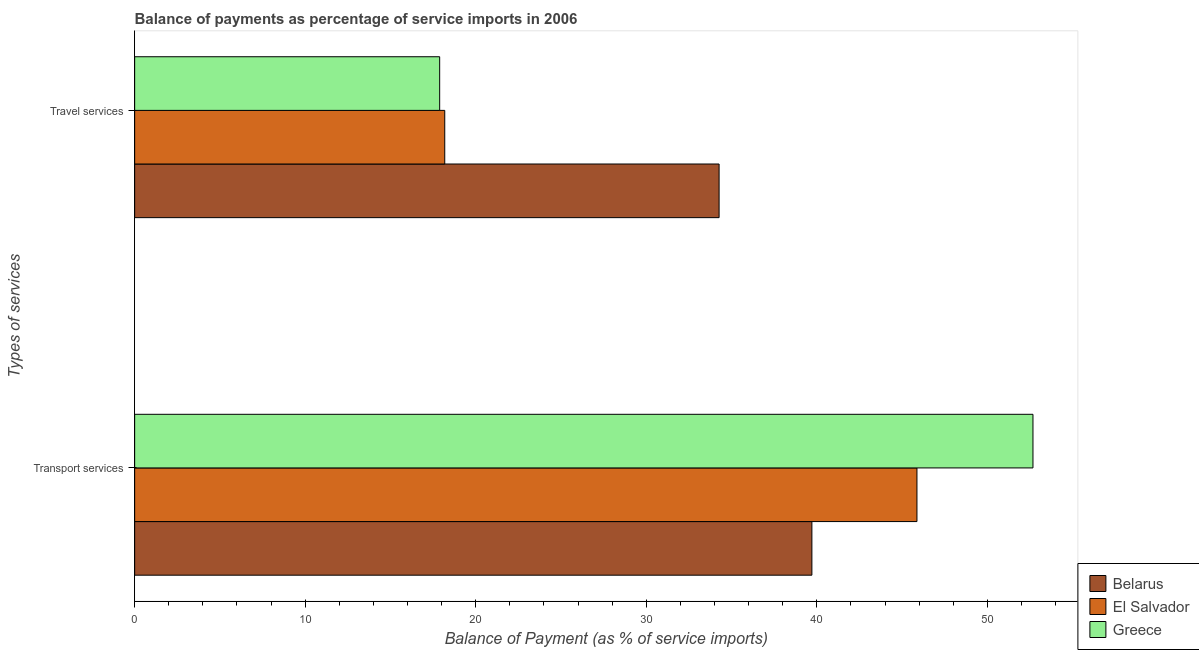How many different coloured bars are there?
Provide a succinct answer. 3. Are the number of bars per tick equal to the number of legend labels?
Keep it short and to the point. Yes. How many bars are there on the 2nd tick from the top?
Your answer should be very brief. 3. What is the label of the 1st group of bars from the top?
Ensure brevity in your answer.  Travel services. What is the balance of payments of travel services in El Salvador?
Offer a very short reply. 18.18. Across all countries, what is the maximum balance of payments of transport services?
Ensure brevity in your answer.  52.67. Across all countries, what is the minimum balance of payments of travel services?
Keep it short and to the point. 17.89. In which country was the balance of payments of transport services minimum?
Your answer should be compact. Belarus. What is the total balance of payments of transport services in the graph?
Offer a terse response. 138.26. What is the difference between the balance of payments of transport services in El Salvador and that in Belarus?
Make the answer very short. 6.16. What is the difference between the balance of payments of travel services in El Salvador and the balance of payments of transport services in Greece?
Offer a very short reply. -34.49. What is the average balance of payments of travel services per country?
Provide a succinct answer. 23.45. What is the difference between the balance of payments of travel services and balance of payments of transport services in El Salvador?
Ensure brevity in your answer.  -27.69. In how many countries, is the balance of payments of travel services greater than 38 %?
Offer a very short reply. 0. What is the ratio of the balance of payments of travel services in Greece to that in Belarus?
Your answer should be very brief. 0.52. Is the balance of payments of travel services in Greece less than that in El Salvador?
Offer a very short reply. Yes. What does the 2nd bar from the top in Travel services represents?
Ensure brevity in your answer.  El Salvador. What does the 2nd bar from the bottom in Transport services represents?
Offer a very short reply. El Salvador. Are all the bars in the graph horizontal?
Make the answer very short. Yes. How many countries are there in the graph?
Keep it short and to the point. 3. What is the difference between two consecutive major ticks on the X-axis?
Offer a very short reply. 10. Are the values on the major ticks of X-axis written in scientific E-notation?
Your answer should be very brief. No. Does the graph contain any zero values?
Offer a very short reply. No. How many legend labels are there?
Offer a terse response. 3. How are the legend labels stacked?
Make the answer very short. Vertical. What is the title of the graph?
Provide a succinct answer. Balance of payments as percentage of service imports in 2006. Does "OECD members" appear as one of the legend labels in the graph?
Your response must be concise. No. What is the label or title of the X-axis?
Provide a short and direct response. Balance of Payment (as % of service imports). What is the label or title of the Y-axis?
Your answer should be very brief. Types of services. What is the Balance of Payment (as % of service imports) in Belarus in Transport services?
Provide a succinct answer. 39.71. What is the Balance of Payment (as % of service imports) in El Salvador in Transport services?
Give a very brief answer. 45.87. What is the Balance of Payment (as % of service imports) of Greece in Transport services?
Your answer should be very brief. 52.67. What is the Balance of Payment (as % of service imports) of Belarus in Travel services?
Offer a terse response. 34.27. What is the Balance of Payment (as % of service imports) of El Salvador in Travel services?
Provide a short and direct response. 18.18. What is the Balance of Payment (as % of service imports) of Greece in Travel services?
Provide a succinct answer. 17.89. Across all Types of services, what is the maximum Balance of Payment (as % of service imports) of Belarus?
Provide a succinct answer. 39.71. Across all Types of services, what is the maximum Balance of Payment (as % of service imports) in El Salvador?
Your answer should be very brief. 45.87. Across all Types of services, what is the maximum Balance of Payment (as % of service imports) of Greece?
Your answer should be very brief. 52.67. Across all Types of services, what is the minimum Balance of Payment (as % of service imports) in Belarus?
Offer a terse response. 34.27. Across all Types of services, what is the minimum Balance of Payment (as % of service imports) in El Salvador?
Provide a short and direct response. 18.18. Across all Types of services, what is the minimum Balance of Payment (as % of service imports) of Greece?
Your answer should be compact. 17.89. What is the total Balance of Payment (as % of service imports) in Belarus in the graph?
Your answer should be very brief. 73.98. What is the total Balance of Payment (as % of service imports) in El Salvador in the graph?
Your answer should be compact. 64.06. What is the total Balance of Payment (as % of service imports) in Greece in the graph?
Offer a terse response. 70.56. What is the difference between the Balance of Payment (as % of service imports) of Belarus in Transport services and that in Travel services?
Offer a terse response. 5.44. What is the difference between the Balance of Payment (as % of service imports) in El Salvador in Transport services and that in Travel services?
Your response must be concise. 27.69. What is the difference between the Balance of Payment (as % of service imports) of Greece in Transport services and that in Travel services?
Ensure brevity in your answer.  34.79. What is the difference between the Balance of Payment (as % of service imports) in Belarus in Transport services and the Balance of Payment (as % of service imports) in El Salvador in Travel services?
Keep it short and to the point. 21.53. What is the difference between the Balance of Payment (as % of service imports) of Belarus in Transport services and the Balance of Payment (as % of service imports) of Greece in Travel services?
Ensure brevity in your answer.  21.83. What is the difference between the Balance of Payment (as % of service imports) of El Salvador in Transport services and the Balance of Payment (as % of service imports) of Greece in Travel services?
Your answer should be very brief. 27.99. What is the average Balance of Payment (as % of service imports) of Belarus per Types of services?
Provide a succinct answer. 36.99. What is the average Balance of Payment (as % of service imports) of El Salvador per Types of services?
Give a very brief answer. 32.03. What is the average Balance of Payment (as % of service imports) in Greece per Types of services?
Provide a short and direct response. 35.28. What is the difference between the Balance of Payment (as % of service imports) of Belarus and Balance of Payment (as % of service imports) of El Salvador in Transport services?
Your answer should be very brief. -6.16. What is the difference between the Balance of Payment (as % of service imports) of Belarus and Balance of Payment (as % of service imports) of Greece in Transport services?
Give a very brief answer. -12.96. What is the difference between the Balance of Payment (as % of service imports) of El Salvador and Balance of Payment (as % of service imports) of Greece in Transport services?
Give a very brief answer. -6.8. What is the difference between the Balance of Payment (as % of service imports) of Belarus and Balance of Payment (as % of service imports) of El Salvador in Travel services?
Provide a succinct answer. 16.09. What is the difference between the Balance of Payment (as % of service imports) of Belarus and Balance of Payment (as % of service imports) of Greece in Travel services?
Keep it short and to the point. 16.38. What is the difference between the Balance of Payment (as % of service imports) in El Salvador and Balance of Payment (as % of service imports) in Greece in Travel services?
Offer a terse response. 0.3. What is the ratio of the Balance of Payment (as % of service imports) in Belarus in Transport services to that in Travel services?
Offer a very short reply. 1.16. What is the ratio of the Balance of Payment (as % of service imports) of El Salvador in Transport services to that in Travel services?
Your answer should be very brief. 2.52. What is the ratio of the Balance of Payment (as % of service imports) in Greece in Transport services to that in Travel services?
Ensure brevity in your answer.  2.94. What is the difference between the highest and the second highest Balance of Payment (as % of service imports) of Belarus?
Provide a succinct answer. 5.44. What is the difference between the highest and the second highest Balance of Payment (as % of service imports) in El Salvador?
Give a very brief answer. 27.69. What is the difference between the highest and the second highest Balance of Payment (as % of service imports) of Greece?
Offer a terse response. 34.79. What is the difference between the highest and the lowest Balance of Payment (as % of service imports) of Belarus?
Give a very brief answer. 5.44. What is the difference between the highest and the lowest Balance of Payment (as % of service imports) in El Salvador?
Provide a short and direct response. 27.69. What is the difference between the highest and the lowest Balance of Payment (as % of service imports) of Greece?
Make the answer very short. 34.79. 